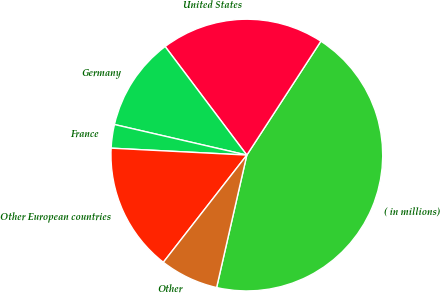Convert chart to OTSL. <chart><loc_0><loc_0><loc_500><loc_500><pie_chart><fcel>( in millions)<fcel>United States<fcel>Germany<fcel>France<fcel>Other European countries<fcel>Other<nl><fcel>44.39%<fcel>19.44%<fcel>11.12%<fcel>2.8%<fcel>15.28%<fcel>6.96%<nl></chart> 